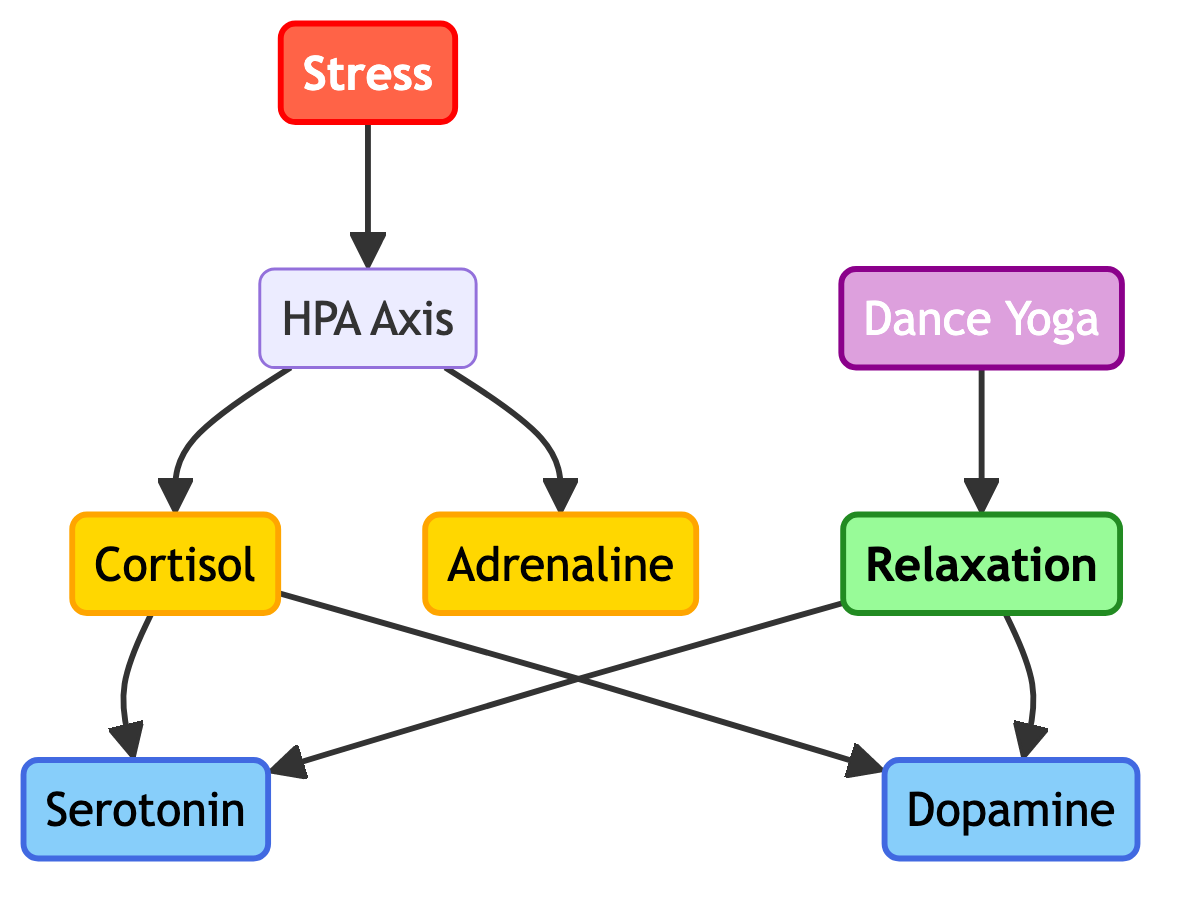What is the number of nodes in the diagram? The diagram contains 8 distinct entities: Stress, HPA Axis, Cortisol, Adrenaline, Serotonin, Dopamine, Relaxation, and Dance Yoga. Thus, the total number of nodes is calculated to be 8.
Answer: 8 Which node follows Cortisol directly in the flow? The edges connected to Cortisol show that Serotonin and Dopamine are the two nodes that directly follow Cortisol in the directed path. However, only one node is requested, so Serotonin can be chosen for this answer.
Answer: Serotonin What type of response does Dance Yoga lead to? The directed edge from Dance Yoga leads directly to Relaxation, indicating that the activity is directed towards achieving a state of Relaxation.
Answer: Relaxation How many edges connect to the HPA Axis? To find the edges connected to HPA Axis, we look at the directed edges originating from it. The HPA Axis has two outgoing edges to Cortisol and Adrenaline. Adding these gives us a total of 2 edges.
Answer: 2 What is the relationship between Stress and Adrenaline? There is a directed edge from Stress to HPA Axis, and then from HPA Axis to Adrenaline, meaning Stress indirectly leads to the production of Adrenaline through the HPA Axis.
Answer: Indirect relation Which hormone is produced as a result of Stress? Following the directed edges from Stress to HPA Axis and then to Cortisol, we see that Cortisol is produced as a direct result of the HPA Axis activation.
Answer: Cortisol What neurotransmitters are influenced by Relaxation? Following the edges from Relaxation, we see that both Serotonin and Dopamine are influenced or produced as a result of entering a state of Relaxation. Thus, both neurotransmitters are relevant here.
Answer: Serotonin and Dopamine What is the initial trigger for the hormonal response depicted in the diagram? The diagram shows that the initial trigger for the hormonal response is Stress, which activates the HPA Axis, leading to further hormonal changes.
Answer: Stress 